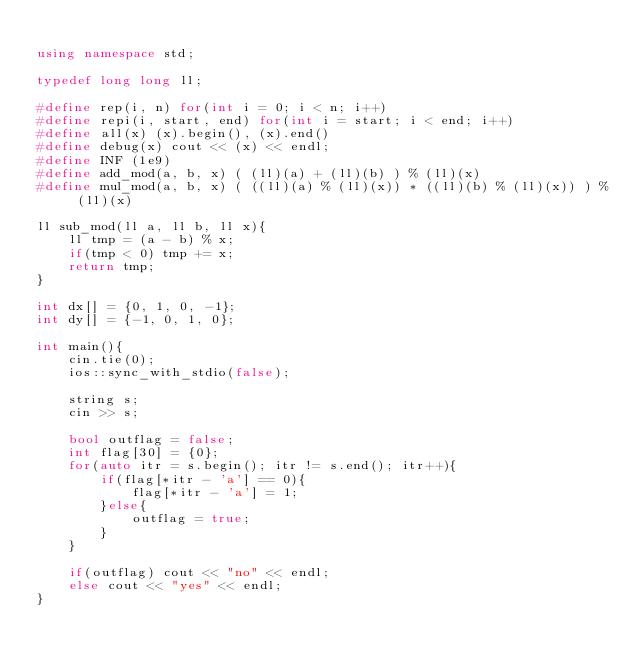<code> <loc_0><loc_0><loc_500><loc_500><_C++_>
using namespace std;

typedef long long ll;

#define rep(i, n) for(int i = 0; i < n; i++)
#define repi(i, start, end) for(int i = start; i < end; i++)
#define all(x) (x).begin(), (x).end()
#define debug(x) cout << (x) << endl;
#define INF (1e9)
#define add_mod(a, b, x) ( (ll)(a) + (ll)(b) ) % (ll)(x)
#define mul_mod(a, b, x) ( ((ll)(a) % (ll)(x)) * ((ll)(b) % (ll)(x)) ) % (ll)(x)

ll sub_mod(ll a, ll b, ll x){
    ll tmp = (a - b) % x;
    if(tmp < 0) tmp += x;
    return tmp;
}

int dx[] = {0, 1, 0, -1};
int dy[] = {-1, 0, 1, 0};

int main(){
    cin.tie(0);
    ios::sync_with_stdio(false);

    string s;
    cin >> s;

    bool outflag = false;
    int flag[30] = {0};
    for(auto itr = s.begin(); itr != s.end(); itr++){
        if(flag[*itr - 'a'] == 0){
            flag[*itr - 'a'] = 1;
        }else{
            outflag = true;
        }
    }

    if(outflag) cout << "no" << endl;
    else cout << "yes" << endl;
}</code> 